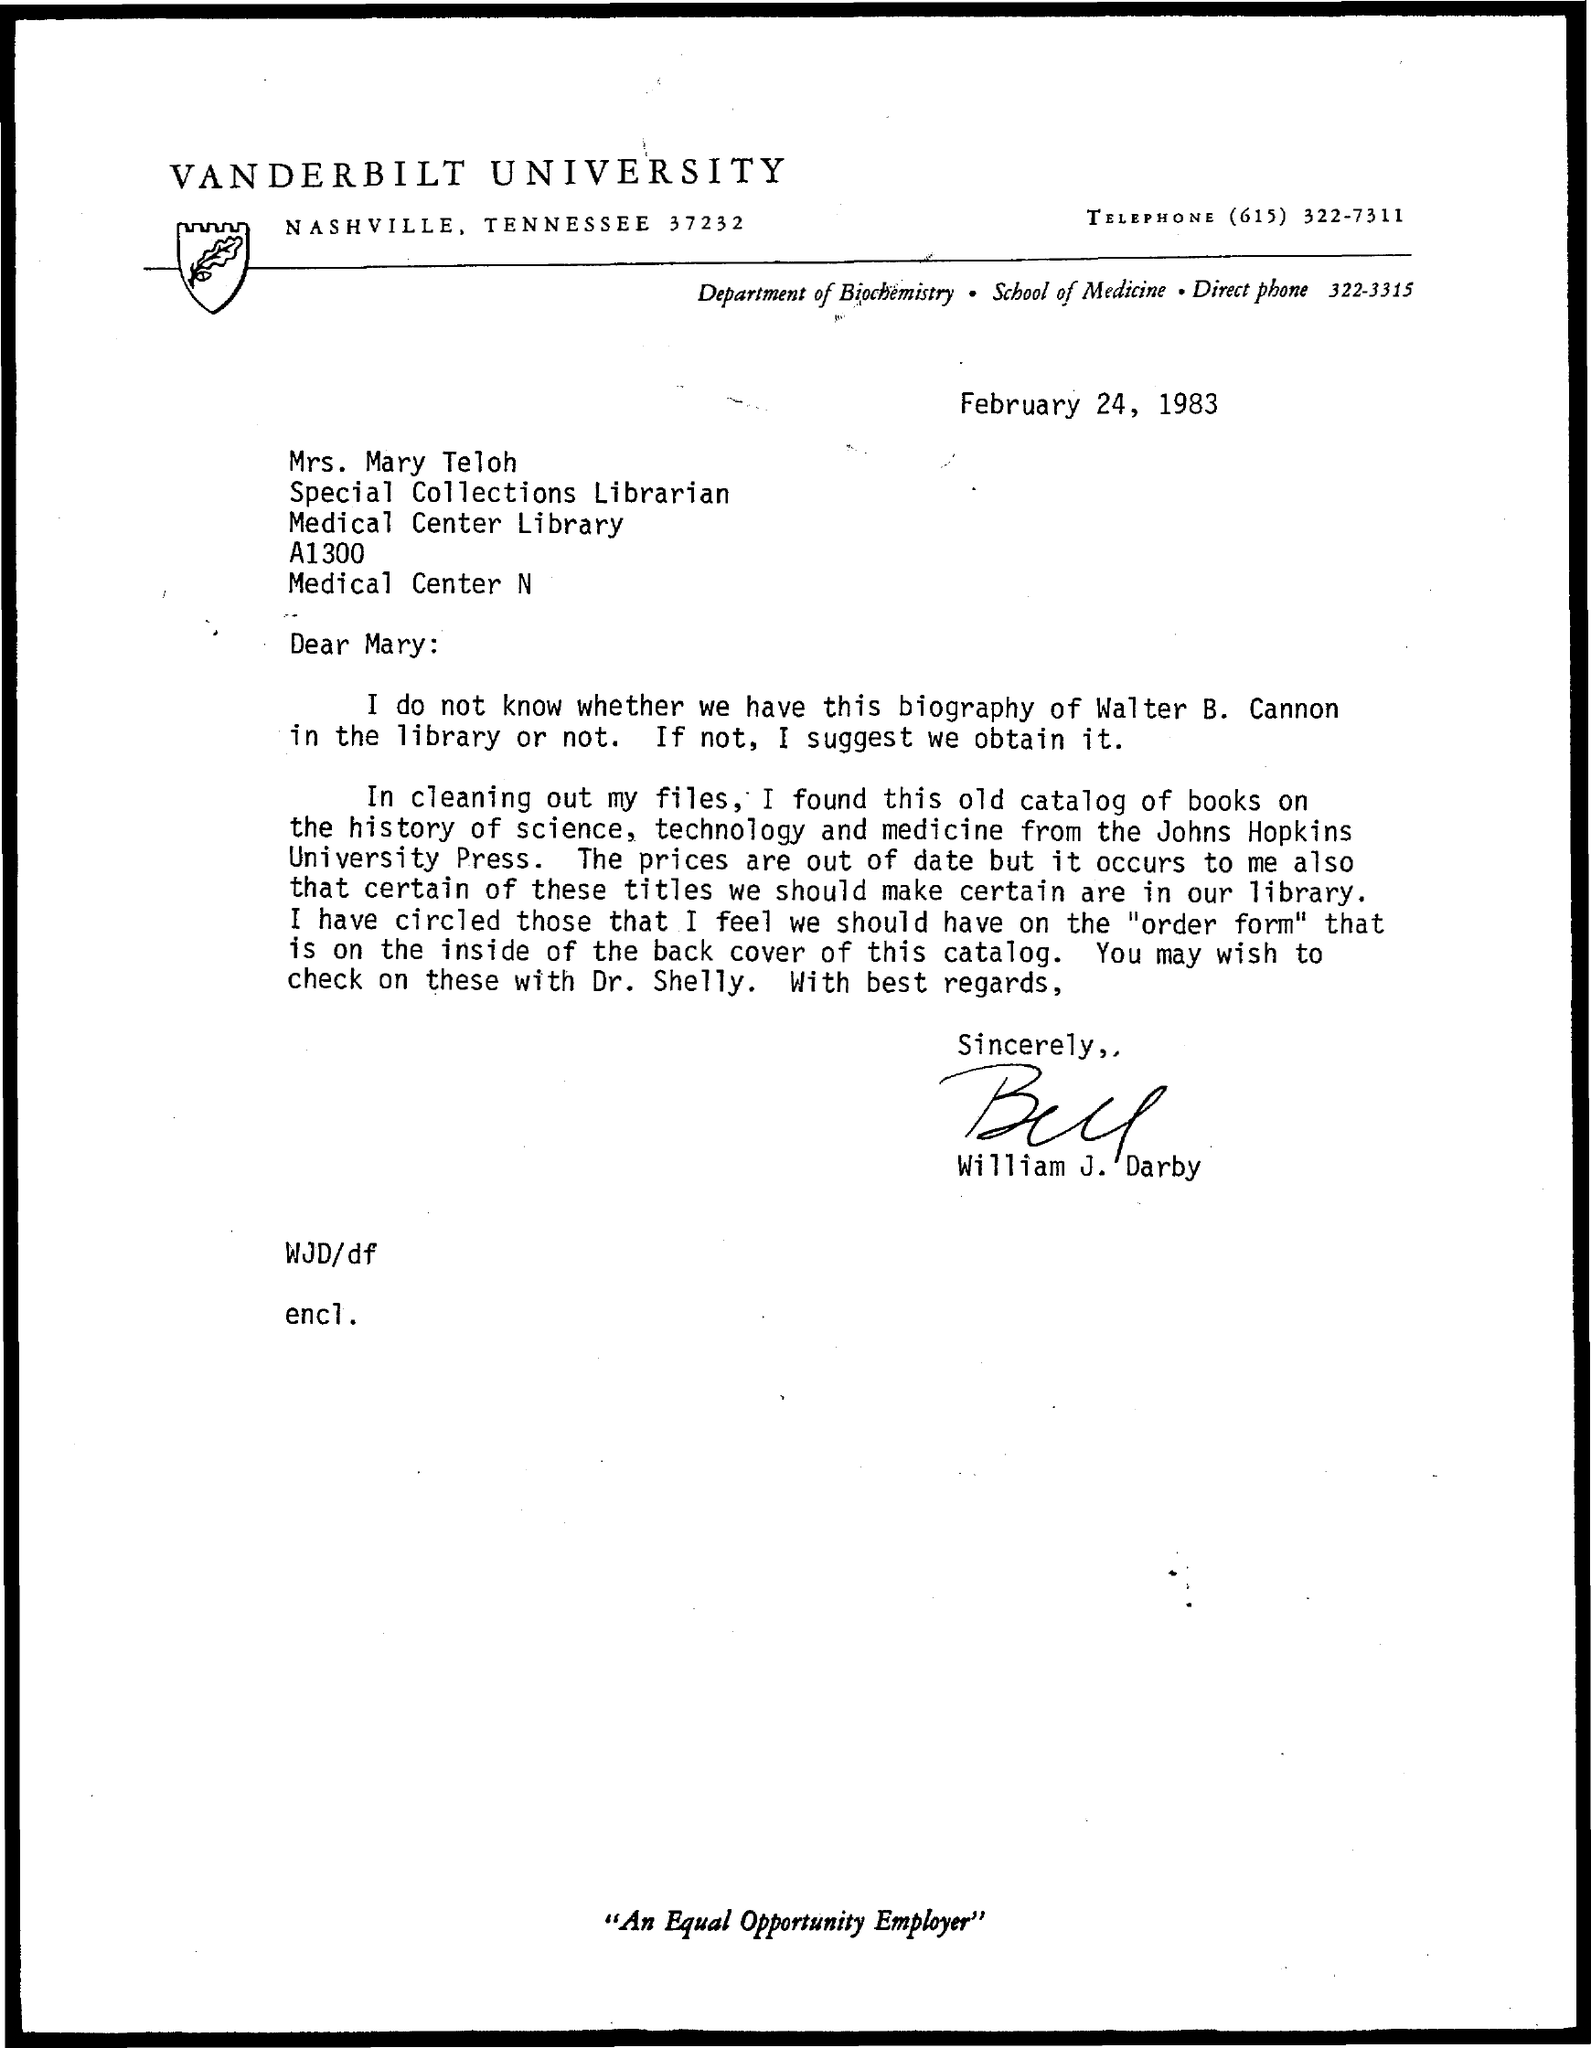Which university is mentioned in the letterhead?
Offer a very short reply. Vanderbilt University. What is the date mentioned in this letter?
Offer a terse response. February 24, 1983. Who has signed this letter?
Keep it short and to the point. William J. Darby. 